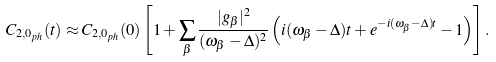Convert formula to latex. <formula><loc_0><loc_0><loc_500><loc_500>C _ { 2 , 0 _ { p h } } ( t ) \approx C _ { 2 , 0 _ { p h } } ( 0 ) \left [ 1 + \sum _ { \beta } \frac { | g _ { \beta } | ^ { 2 } } { ( \omega _ { \beta } - \Delta ) ^ { 2 } } \left ( i ( \omega _ { \beta } - \Delta ) t + e ^ { - i ( \omega _ { \beta } - \Delta ) t } - 1 \right ) \right ] .</formula> 